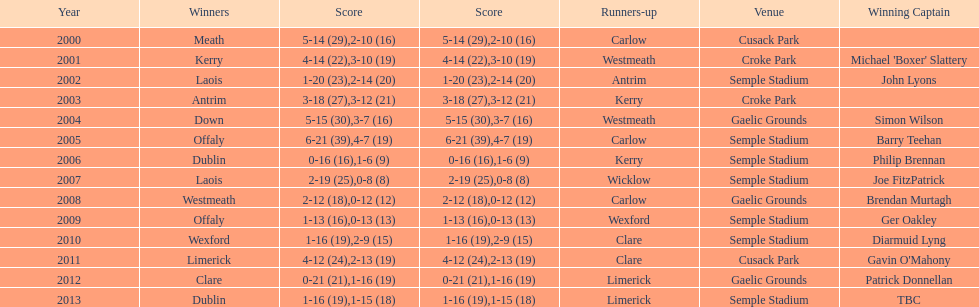How many instances was carlow the second-place finisher? 3. 